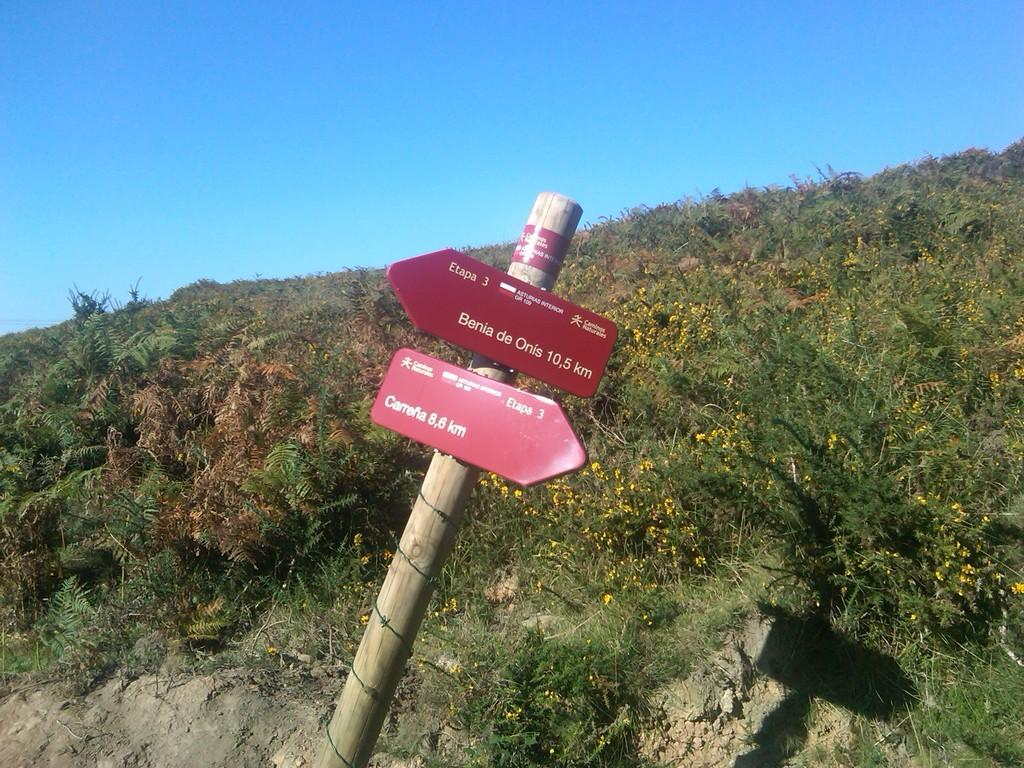What is the main object in the image? There is a sign board in the image. What is the color of the sign board? The sign board is red in color. How is the sign board positioned in the image? The sign board is attached to a pole. What type of vegetation can be seen in the image? There are flowers and plants in the image. What part of the natural environment is visible in the image? The sky is visible in the image. What type of food is being sold on the shelf in the image? There is no shelf or food present in the image; it features a red sign board attached to a pole, flowers, plants, and the sky. 